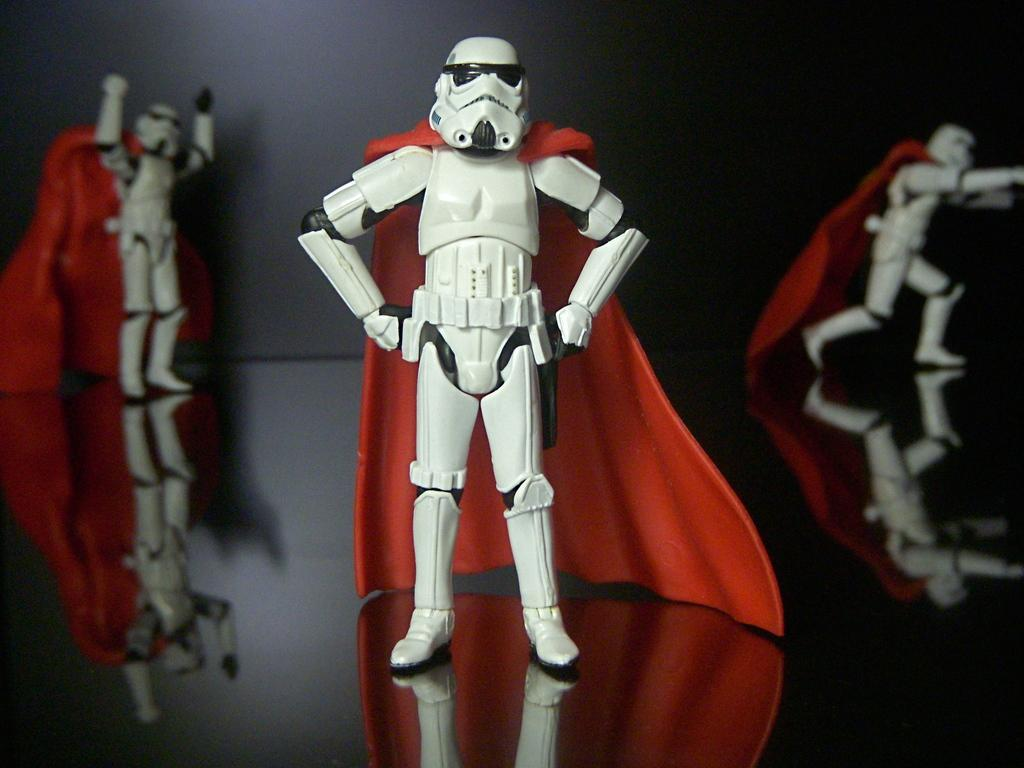What color are the toys in the image? The toys in the image are white. Is there a wound visible on any of the white toys in the image? There is no mention of a wound in the image, and the toys appear to be intact. 